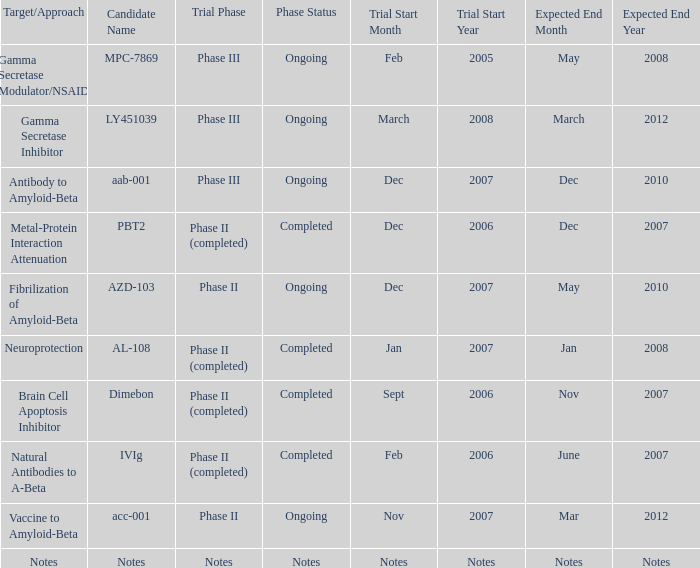When the target/strategy is notes, what is the projected end date? Notes. 